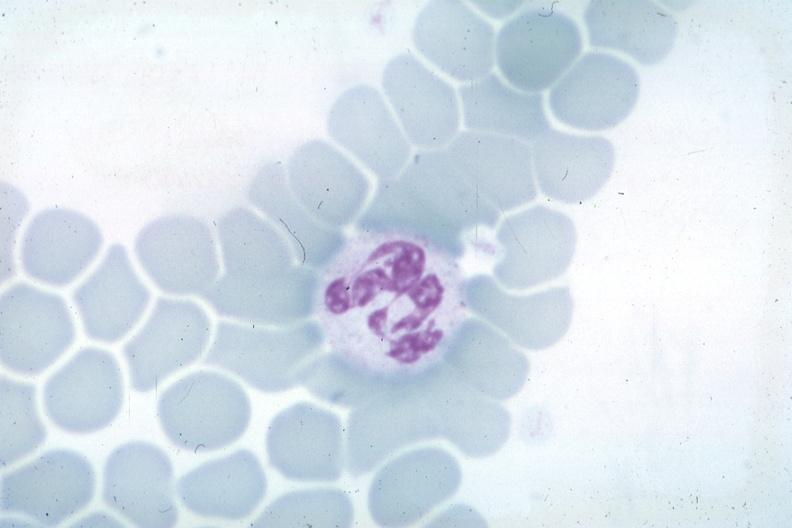s colon obvious source unknown?
Answer the question using a single word or phrase. No 